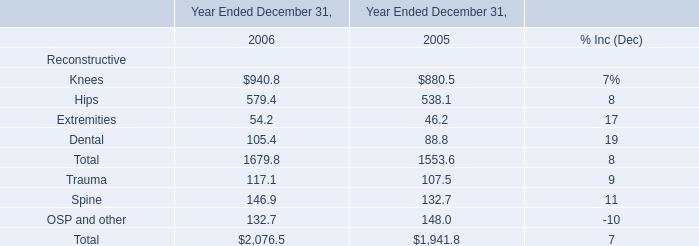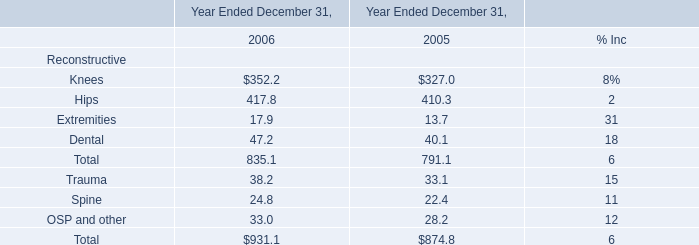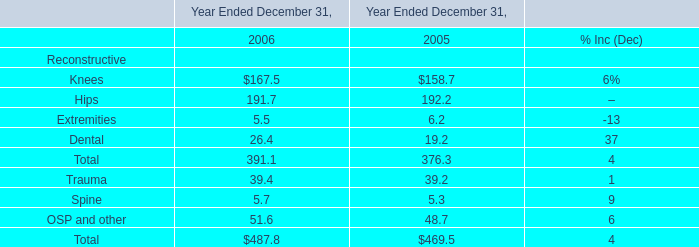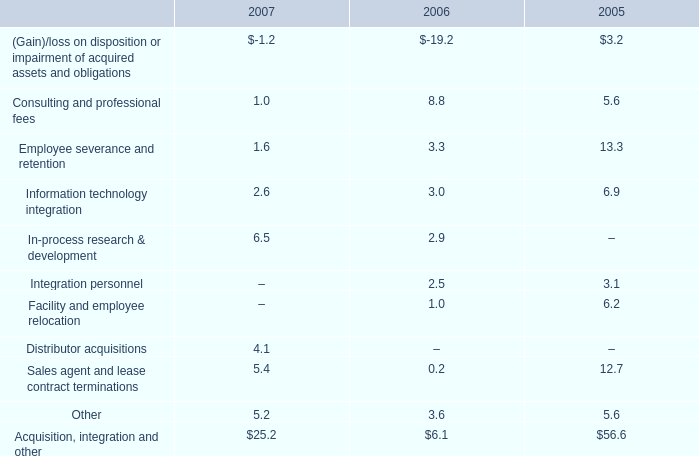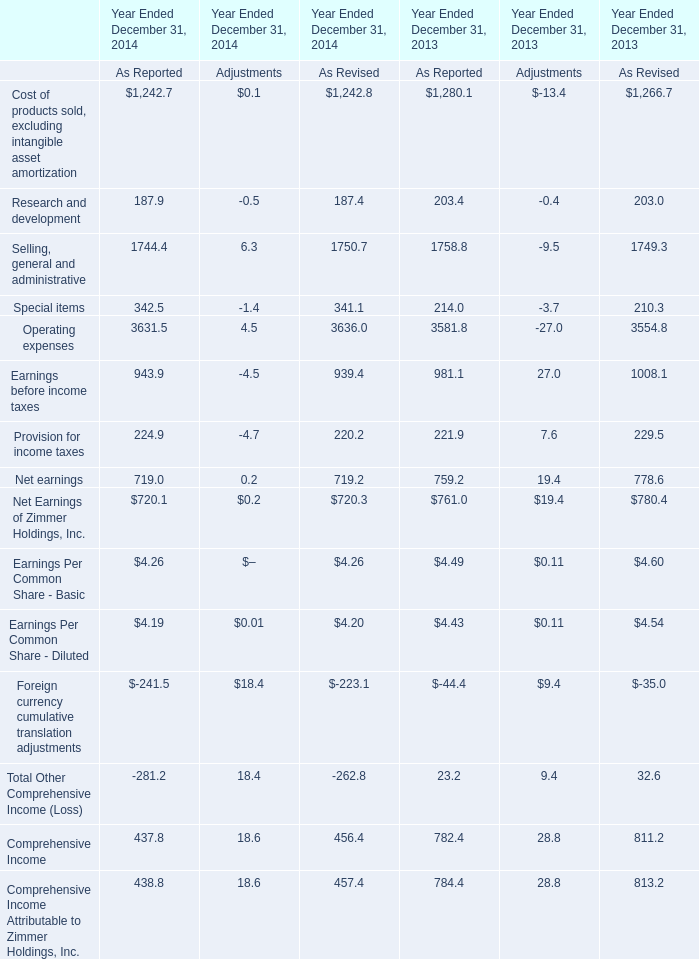what is the percent change in consulting and professional fees from 2006 to 2007? 
Computations: ((8.8 - 1.0) / 1.0)
Answer: 7.8. 